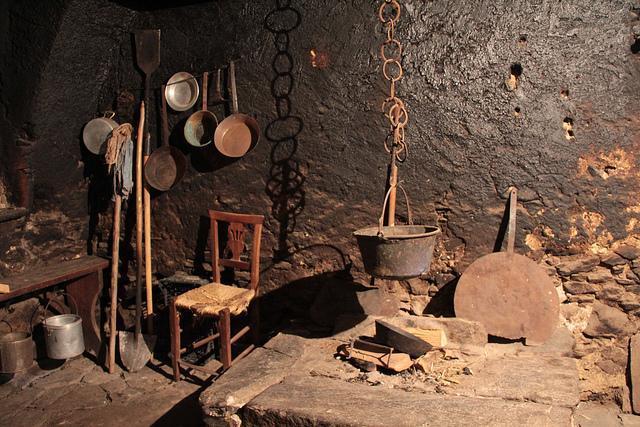How many pins are on the wall?
Give a very brief answer. 5. 